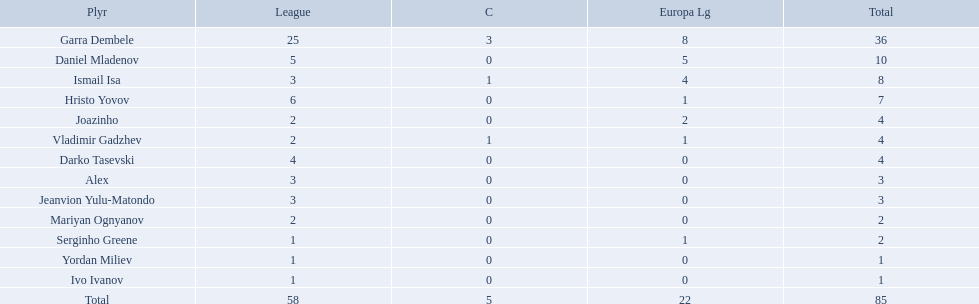What league is 2? 2, 2, 2. Which cup is less than 1? 0, 0. Which total is 2? 2. Who is the player? Mariyan Ognyanov. Who are all of the players? Garra Dembele, Daniel Mladenov, Ismail Isa, Hristo Yovov, Joazinho, Vladimir Gadzhev, Darko Tasevski, Alex, Jeanvion Yulu-Matondo, Mariyan Ognyanov, Serginho Greene, Yordan Miliev, Ivo Ivanov. And which league is each player in? 25, 5, 3, 6, 2, 2, 4, 3, 3, 2, 1, 1, 1. Along with vladimir gadzhev and joazinho, which other player is in league 2? Mariyan Ognyanov. What players did not score in all 3 competitions? Daniel Mladenov, Hristo Yovov, Joazinho, Darko Tasevski, Alex, Jeanvion Yulu-Matondo, Mariyan Ognyanov, Serginho Greene, Yordan Miliev, Ivo Ivanov. Which of those did not have total more then 5? Darko Tasevski, Alex, Jeanvion Yulu-Matondo, Mariyan Ognyanov, Serginho Greene, Yordan Miliev, Ivo Ivanov. Which ones scored more then 1 total? Darko Tasevski, Alex, Jeanvion Yulu-Matondo, Mariyan Ognyanov. Which of these player had the lease league points? Mariyan Ognyanov. 